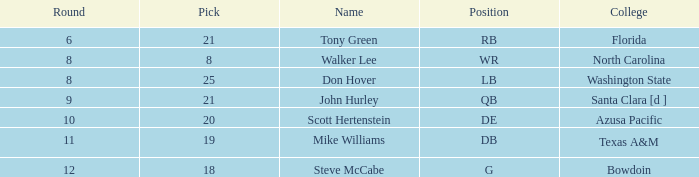Which college has a pick less than 25, an overall greater than 159, a round less than 10, and wr as the position? North Carolina. 